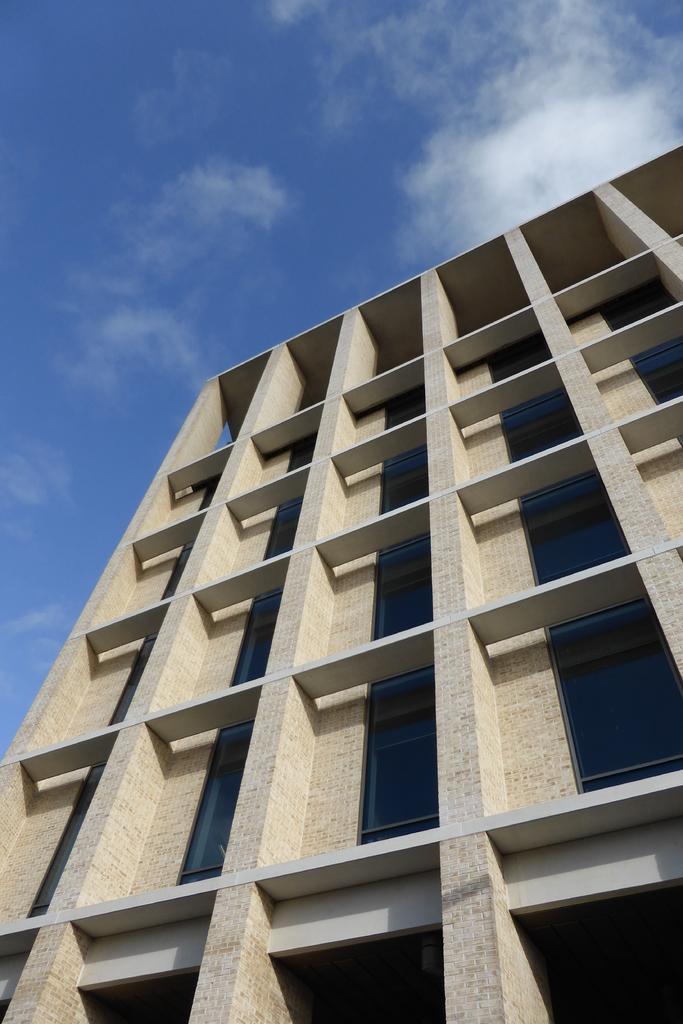Describe this image in one or two sentences. In this image there is a building. There are windows with the glasses. There are clouds in the sky. 